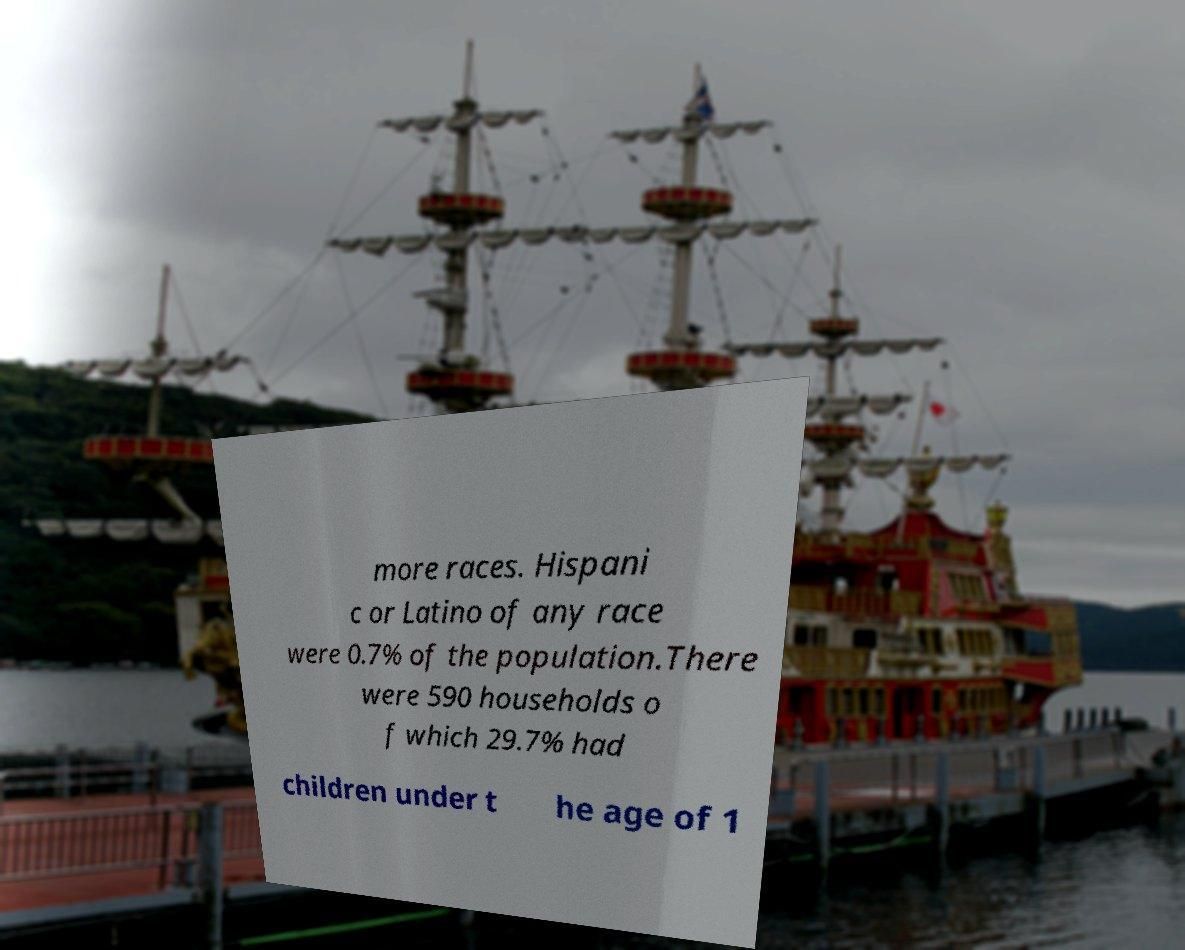What messages or text are displayed in this image? I need them in a readable, typed format. more races. Hispani c or Latino of any race were 0.7% of the population.There were 590 households o f which 29.7% had children under t he age of 1 